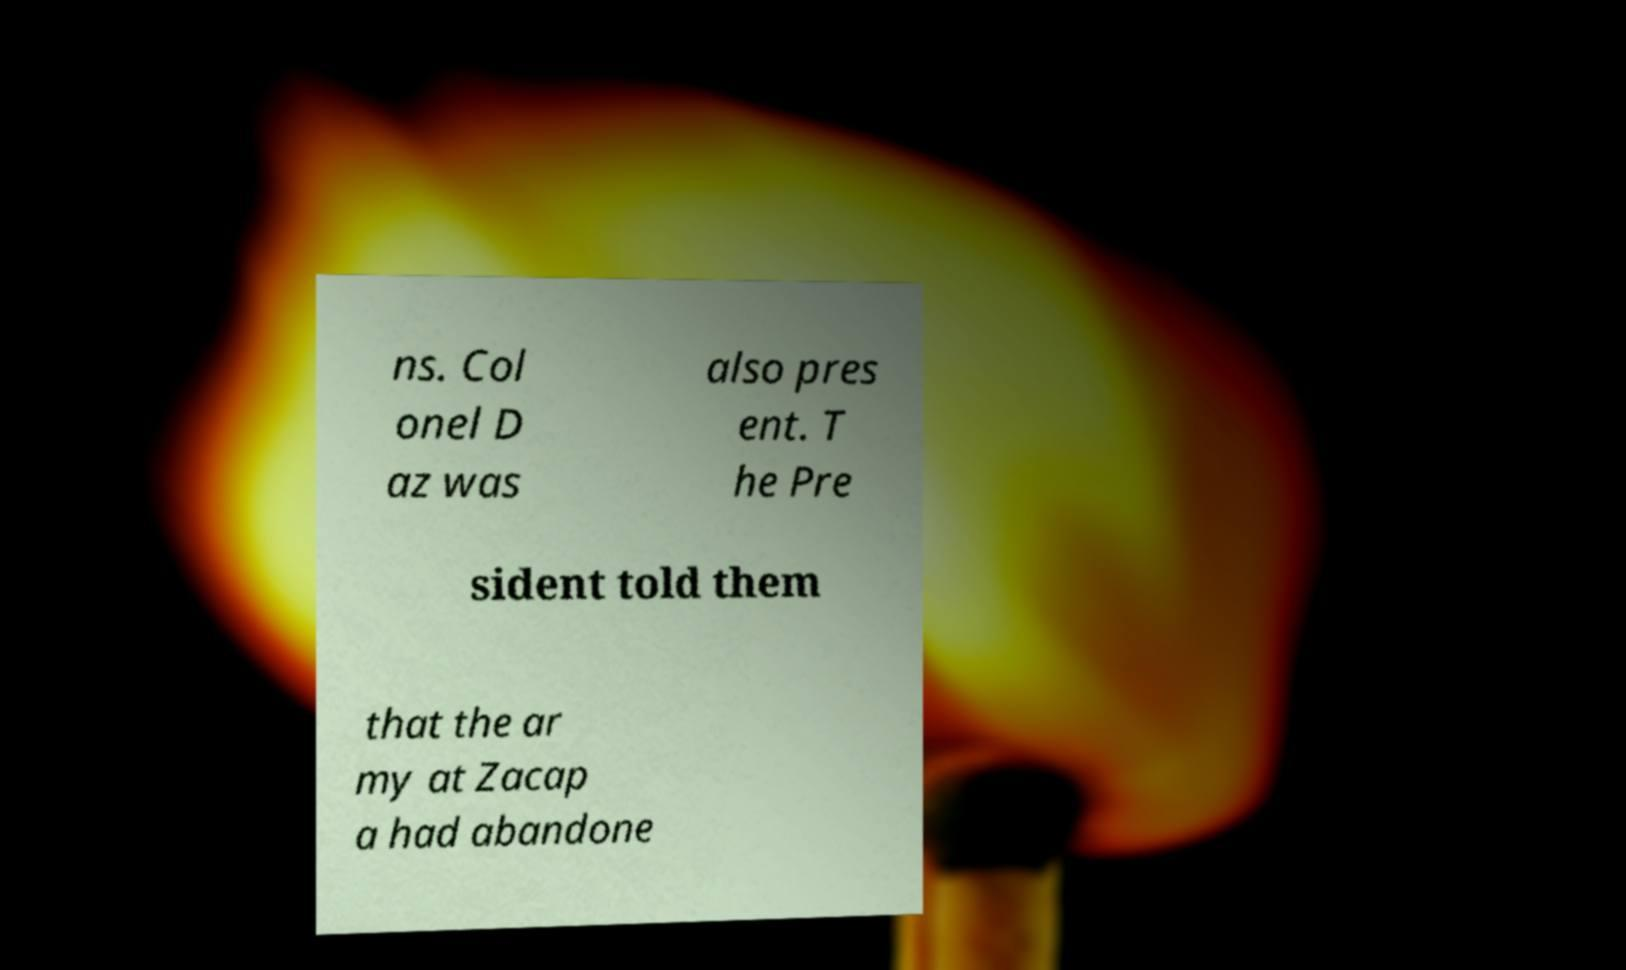I need the written content from this picture converted into text. Can you do that? ns. Col onel D az was also pres ent. T he Pre sident told them that the ar my at Zacap a had abandone 